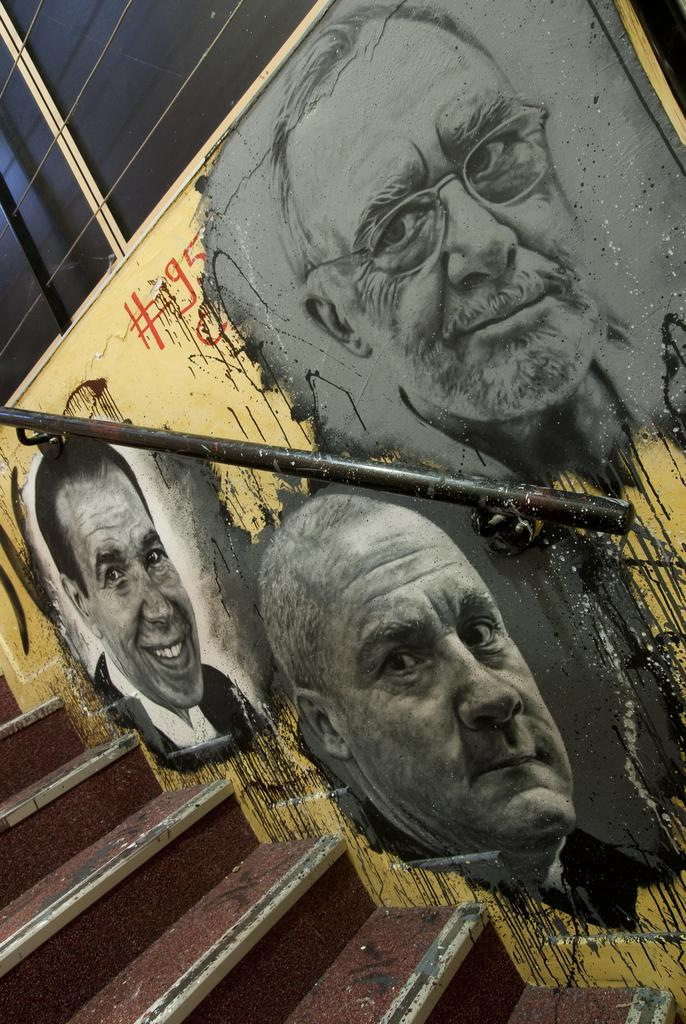What is depicted on the painting that is on the wall in the image? There is a painting of people on the wall in the image. What feature can be seen on the wall besides the painting? There is a handrail on the wall in the image. What architectural element is present in the image? There is a staircase in the image. What can be seen at the top of the staircase? There is a window at the top of the staircase. What type of cannon is present on the staircase in the image? There is no cannon present on the staircase in the image. What kind of produce is being sold in the painting on the wall? The painting on the wall does not depict any produce being sold; it features people. 